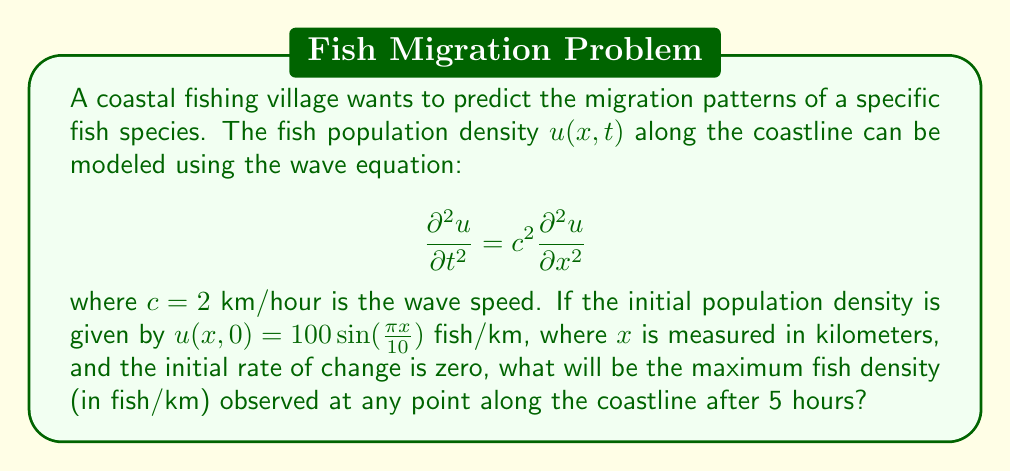Teach me how to tackle this problem. To solve this problem, we'll use the general solution of the 1D wave equation with the given initial conditions:

1) The general solution for the wave equation is:
   $$u(x,t) = f(x-ct) + g(x+ct)$$

2) Given the initial conditions:
   $$u(x,0) = 100 \sin(\frac{\pi x}{10})$$
   $$\frac{\partial u}{\partial t}(x,0) = 0$$

3) These conditions lead to the specific solution:
   $$u(x,t) = 50 \sin(\frac{\pi(x-ct)}{10}) + 50 \sin(\frac{\pi(x+ct)}{10})$$

4) Using the trigonometric identity for the sum of sines:
   $$u(x,t) = 100 \sin(\frac{\pi x}{10}) \cos(\frac{\pi ct}{10})$$

5) The maximum value of sine is 1, so the maximum density at any point will occur when:
   $$\sin(\frac{\pi x}{10}) = 1 \quad \text{and} \quad \cos(\frac{\pi ct}{10}) = 1$$

6) After 5 hours, with $c = 2$ km/hour:
   $$\cos(\frac{\pi \cdot 2 \cdot 5}{10}) = \cos(\pi) = -1$$

7) Therefore, the maximum density after 5 hours will be:
   $$u_{max} = 100 \cdot 1 \cdot |-1| = 100 \text{ fish/km}$$
Answer: 100 fish/km 